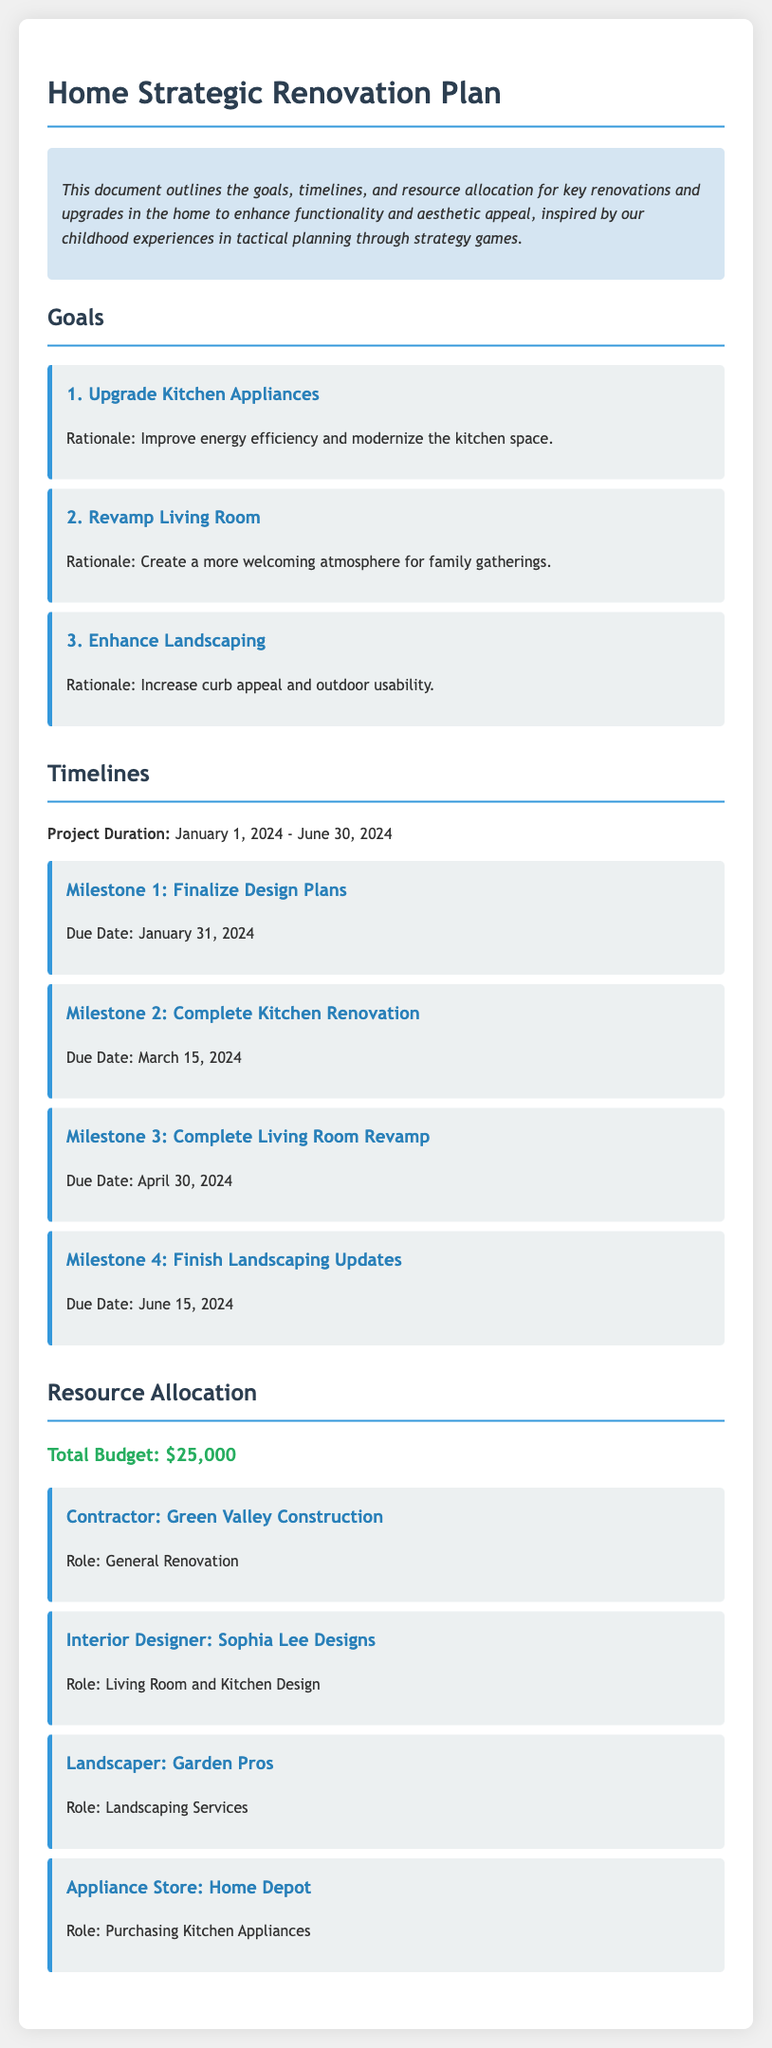What is the project duration? The project duration is specified in the timelines section, which outlines the period from January 1, 2024 to June 30, 2024.
Answer: January 1, 2024 - June 30, 2024 Who is responsible for the landscaping services? The landscaping services are allocated to a specific resource, which is Garden Pros, mentioned in the resource allocation section.
Answer: Garden Pros What is the total budget for the renovations? The total budget is provided in the resource allocation section, highlighting the overall financial resource available for the project.
Answer: $25,000 When is the completion date for the living room revamp? The completion date for the living room revamp is included in the milestones section, indicating the specific due date for this renovation task.
Answer: April 30, 2024 What is the rationale for upgrading kitchen appliances? The rationale for upgrading kitchen appliances is explained in the goals section, detailing the motivation behind this specific renovation goal.
Answer: Improve energy efficiency and modernize the kitchen space Which contractor is hired for general renovation? The contractor responsible for general renovation is listed in the resource allocation section, providing their name and role related to the project.
Answer: Green Valley Construction What is the first milestone in the project timeline? The first milestone is identified in the timelines section, indicating the initial project goal and its respective due date.
Answer: Finalize Design Plans What is the role of Sophia Lee Designs? The role of Sophia Lee Designs is described in the resource allocation section, specifying their contribution to the renovation project.
Answer: Living Room and Kitchen Design 